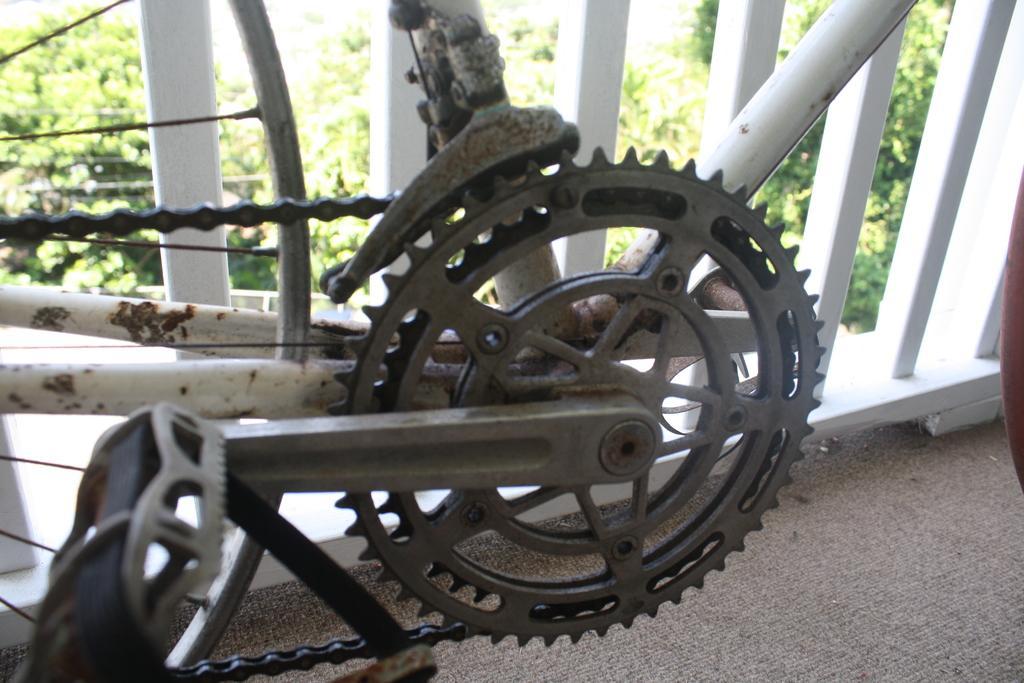How would you summarize this image in a sentence or two? In this image I can see cycle chain, background I can see railing and trees in green color. 